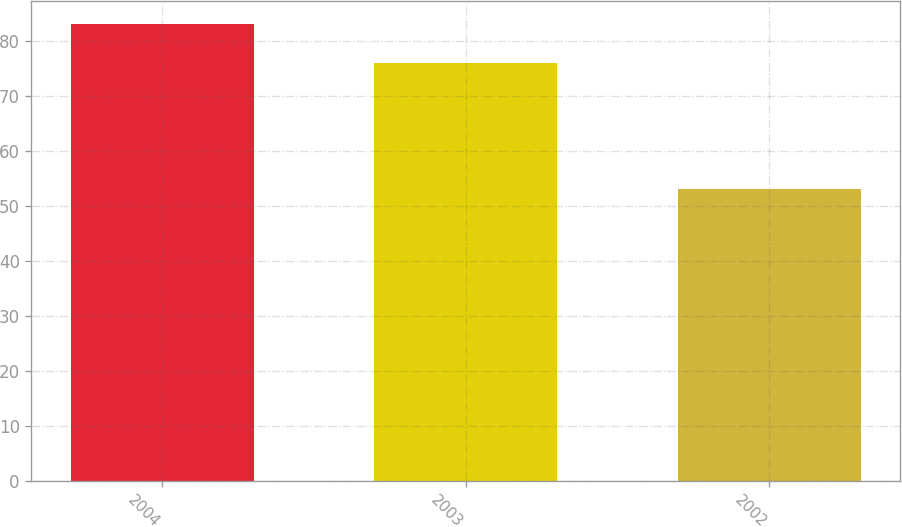Convert chart. <chart><loc_0><loc_0><loc_500><loc_500><bar_chart><fcel>2004<fcel>2003<fcel>2002<nl><fcel>83<fcel>76<fcel>53<nl></chart> 